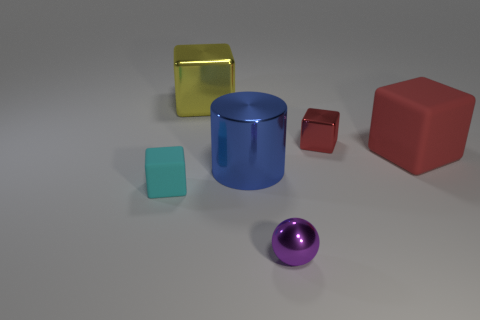What size is the shiny object that is the same color as the big rubber object?
Offer a very short reply. Small. There is a big matte cube; does it have the same color as the small metal object behind the large blue object?
Offer a very short reply. Yes. Are there an equal number of large red matte objects that are in front of the large yellow metallic cube and metal cylinders that are to the left of the big cylinder?
Offer a very short reply. No. How many other tiny shiny things have the same shape as the tiny red thing?
Offer a very short reply. 0. Is there a metallic cube?
Make the answer very short. Yes. Does the sphere have the same material as the object that is on the left side of the yellow metallic block?
Your response must be concise. No. There is a purple object that is the same size as the cyan matte cube; what is it made of?
Your answer should be compact. Metal. Is there another block made of the same material as the small red block?
Offer a very short reply. Yes. There is a large metallic object in front of the big cube that is left of the large red block; is there a purple object right of it?
Provide a short and direct response. Yes. There is a purple thing that is the same size as the red metal block; what is its shape?
Offer a terse response. Sphere. 